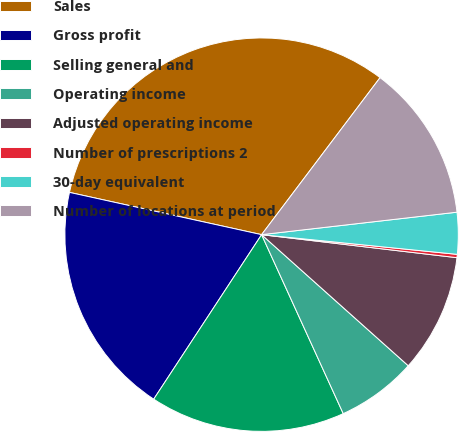<chart> <loc_0><loc_0><loc_500><loc_500><pie_chart><fcel>Sales<fcel>Gross profit<fcel>Selling general and<fcel>Operating income<fcel>Adjusted operating income<fcel>Number of prescriptions 2<fcel>30-day equivalent<fcel>Number of locations at period<nl><fcel>31.84%<fcel>19.21%<fcel>16.05%<fcel>6.58%<fcel>9.74%<fcel>0.27%<fcel>3.42%<fcel>12.89%<nl></chart> 